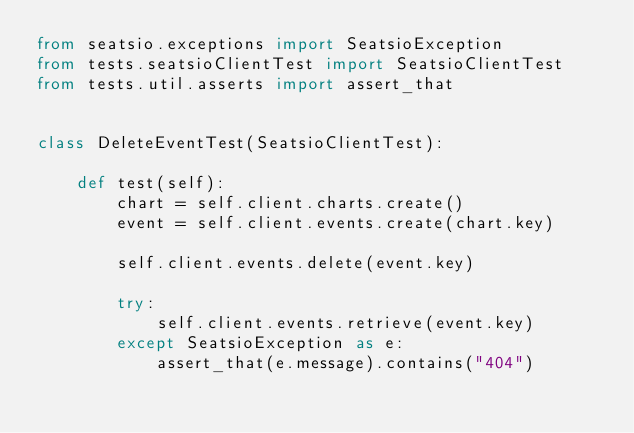Convert code to text. <code><loc_0><loc_0><loc_500><loc_500><_Python_>from seatsio.exceptions import SeatsioException
from tests.seatsioClientTest import SeatsioClientTest
from tests.util.asserts import assert_that


class DeleteEventTest(SeatsioClientTest):

    def test(self):
        chart = self.client.charts.create()
        event = self.client.events.create(chart.key)

        self.client.events.delete(event.key)

        try:
            self.client.events.retrieve(event.key)
        except SeatsioException as e:
            assert_that(e.message).contains("404")
</code> 